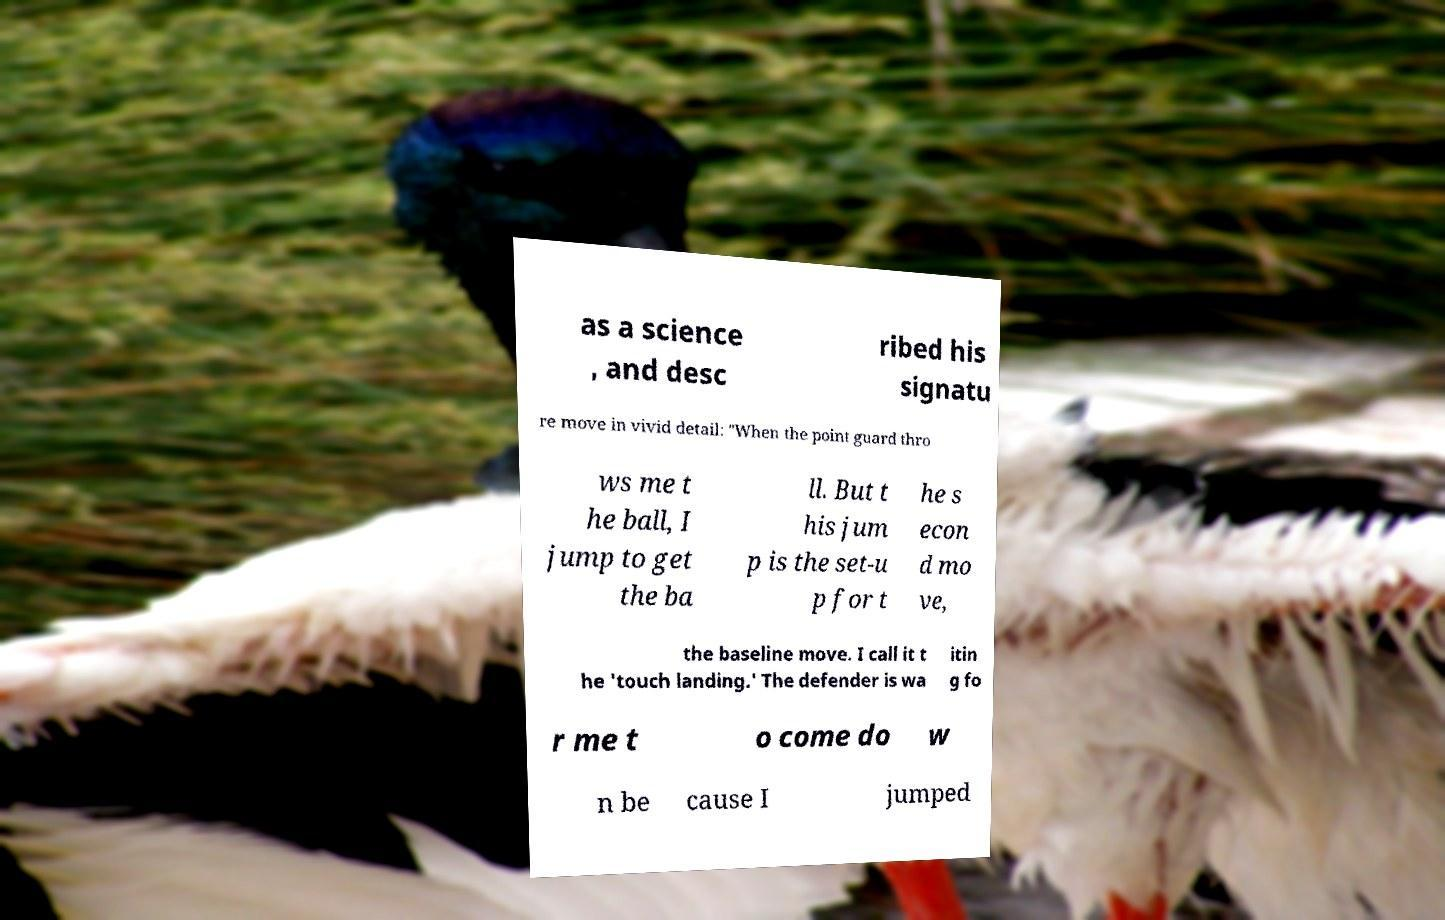Could you assist in decoding the text presented in this image and type it out clearly? as a science , and desc ribed his signatu re move in vivid detail: "When the point guard thro ws me t he ball, I jump to get the ba ll. But t his jum p is the set-u p for t he s econ d mo ve, the baseline move. I call it t he 'touch landing.' The defender is wa itin g fo r me t o come do w n be cause I jumped 